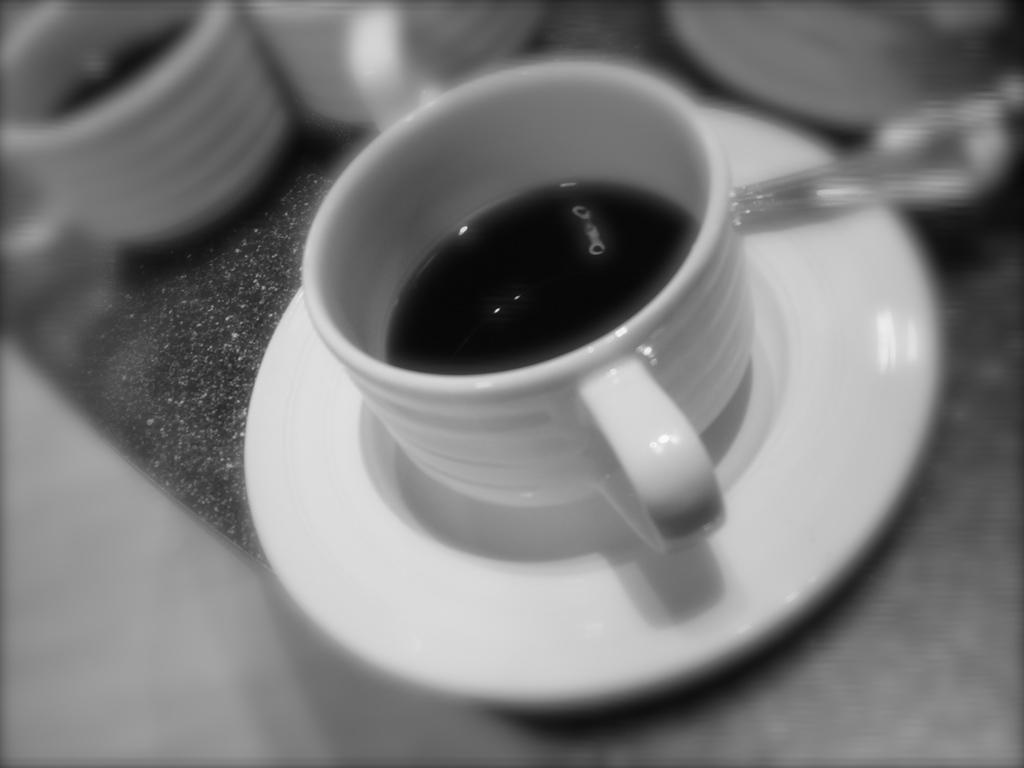What is the color scheme of the image? The image is black and white. What can be seen inside the cups in the image? There are cups with a drink in the image. What utensil is present in the image? There is a spoon in the image. What is used to hold the cup in the image? There is a saucer in the image. What piece of furniture is at the bottom of the image? There is a table at the bottom of the image. What type of maid is serving the drink in the image? There is no maid present in the image; it only features cups, a spoon, a saucer, and a table. What type of battle is depicted in the image? There is no battle depicted in the image; it is a still image of cups, a spoon, a saucer, and a table. 